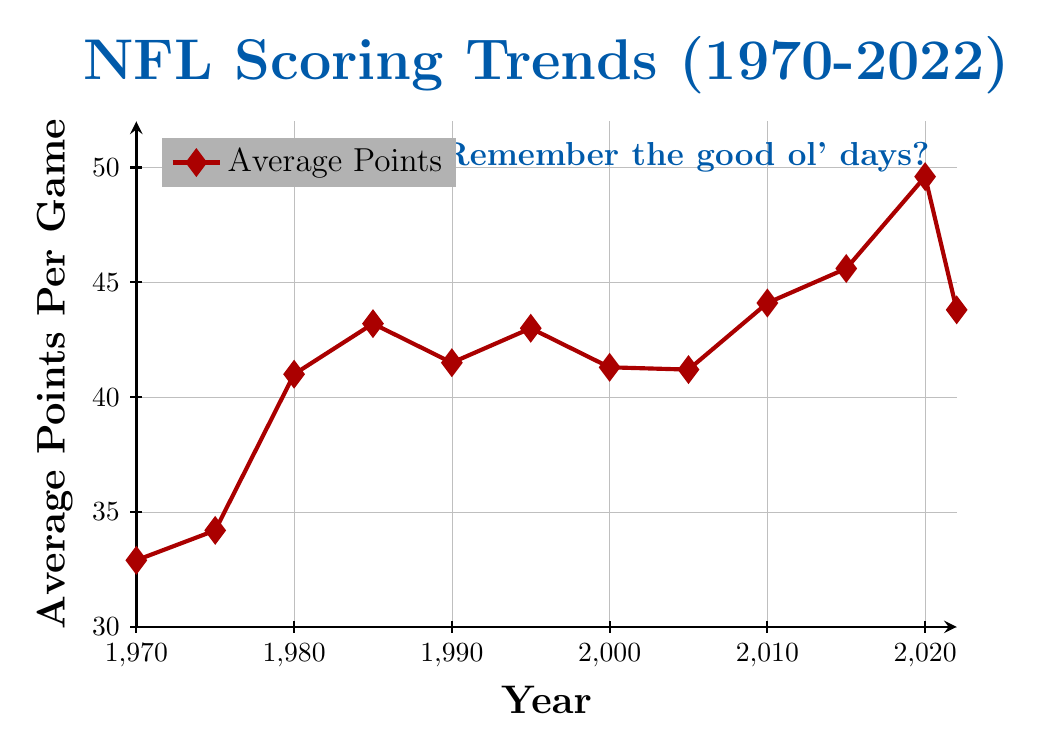What was the average points per game in 1980? Locate the data point for the year 1980 on the x-axis, and identify its corresponding value on the y-axis which represents average points per game.
Answer: 41.0 Which year had the highest average points per game? Compare all the y-axis values and identify the year with the maximum value.
Answer: 2020 How much did the average points per game increase from 1975 to 1985? Subtract the value for 1975 from the value for 1985. Calculation: 43.2 - 34.2 = 9.0
Answer: 9.0 In what year was the average points per game approximately 45? Find the data point where the y-axis value is closest to 45.
Answer: 2015 By how many points did the average per game change from 2010 to 2022? Subtract the value for 2010 from the value for 2022. Calculation: 43.8 - 44.1 = -0.3
Answer: -0.3 Summing up the average points per game values for the years 1970, 1980, and 2022, what is the total? Add the values for the years 1970, 1980, and 2022. Calculation: 32.9 + 41.0 + 43.8 = 117.7
Answer: 117.7 During which 5-year span did the average points per game see the largest increase? Calculate the difference between successive 5-year intervals and identify the maximum. Observation: Largest increase was between 2015 (45.6) and 2020 (49.6). Difference is 4.0
Answer: 2015 to 2020 What is the average value of the average points per game across all listed years? Sum all the y-axis values and divide by the number of data points. Calculation: (32.9 + 34.2 + 41.0 + 43.2 + 41.5 + 43.0 + 41.3 + 41.2 + 44.1 + 45.6 + 49.6 + 43.8) / 12 = 539.4 / 12 = 44.95
Answer: 44.95 Compare the average points per game in 2000 and 2010, which year had a higher value? Find the y-axis values for 2000 and 2010 and compare them. 2010 (44.1) - 2000 (41.3) = 2.8
Answer: 2010 Over the entire span shown in the plot, how many years had an average points per game greater than 42? Count the number of years with y-axis values greater than 42. The years are 1985, 1995, 2010, 2015, 2020, 2022 (6 years total).
Answer: 6 